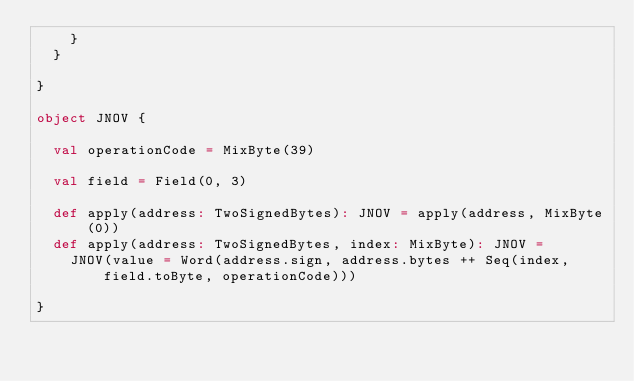Convert code to text. <code><loc_0><loc_0><loc_500><loc_500><_Scala_>    }
  }

}

object JNOV {

  val operationCode = MixByte(39)

  val field = Field(0, 3)

  def apply(address: TwoSignedBytes): JNOV = apply(address, MixByte(0))
  def apply(address: TwoSignedBytes, index: MixByte): JNOV =
    JNOV(value = Word(address.sign, address.bytes ++ Seq(index, field.toByte, operationCode)))

}</code> 